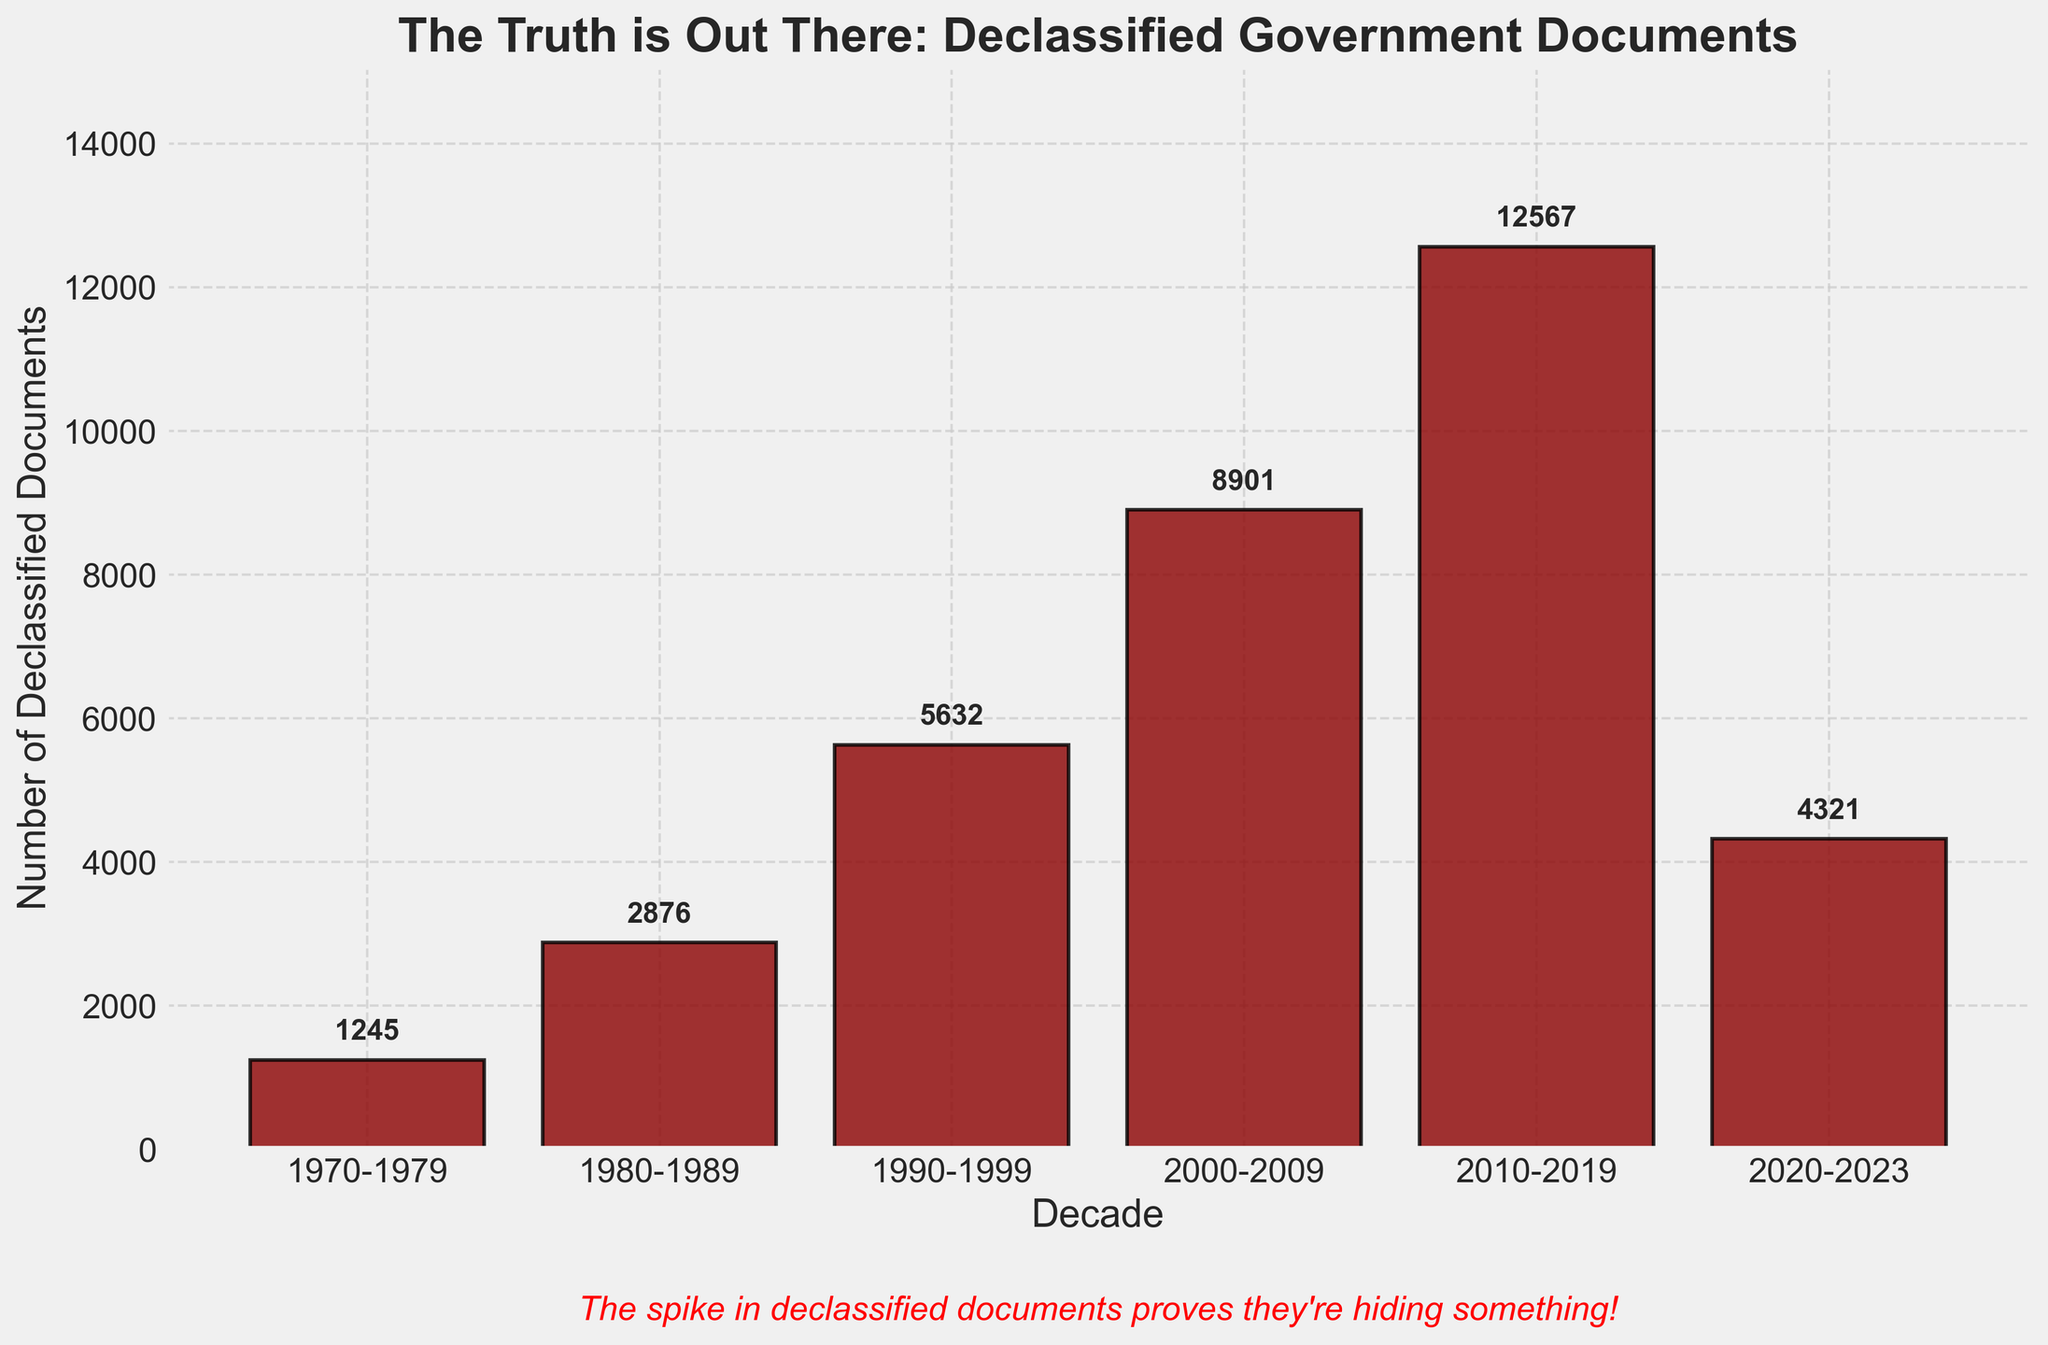What is the title of the figure? The title of the figure is displayed at the top in large, bold font.
Answer: The Truth is Out There: Declassified Government Documents How many decades are represented in the figure? Count the number of distinct decade labels on the x-axis.
Answer: 6 Which decade had the most declassified documents? Identify the tallest bar in the histogram, representing the highest number of declassified documents.
Answer: 2010-2019 What is the color of the bars in the histogram? Observe the color of the bars visually.
Answer: Dark Red What is the number of declassified documents in the 1990-1999 decade? Look at the bar corresponding to 1990-1999 and note the label at the top of the bar.
Answer: 5632 What is the total number of declassified documents from 1970 to 1999? Sum the number of declassified documents from 1970-1979, 1980-1989, and 1990-1999. 1245 + 2876 + 5632 = 9753
Answer: 9753 How many more documents were declassified in the 2000-2009 decade compared to the 1980-1989 decade? Subtract the number of documents in 1980-1989 from the number in 2000-2009. 8901 - 2876 = 6025
Answer: 6025 By what percentage did the number of declassified documents increase from 1990-1999 to 2000-2009? Calculate the percentage increase using the formula: ((new number - old number) / old number) x 100%. ((8901 - 5632) / 5632) x 100% = (3269 / 5632) x 100% ≈ 58.04%
Answer: 58.04% Which decade had the least number of declassified documents? Identify the shortest bar in the histogram, representing the lowest number of declassified documents.
Answer: 1970-1979 How has the trend of declassified documents changed over the decades? Observe the heights of the bars from left to right and describe the overall pattern.
Answer: Generally increasing, with a peak in 2010-2019 